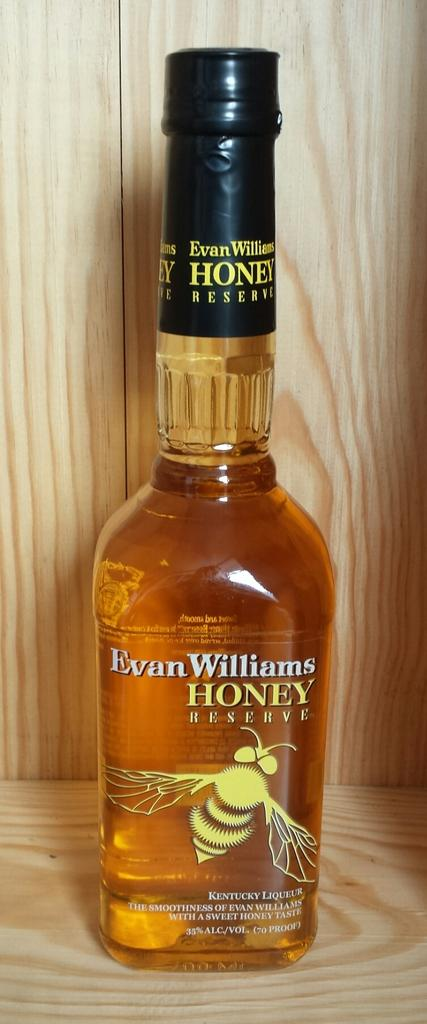<image>
Relay a brief, clear account of the picture shown. Bottle of alcohol named Evan Williams Honey Reserve on top of a wooden surface. 